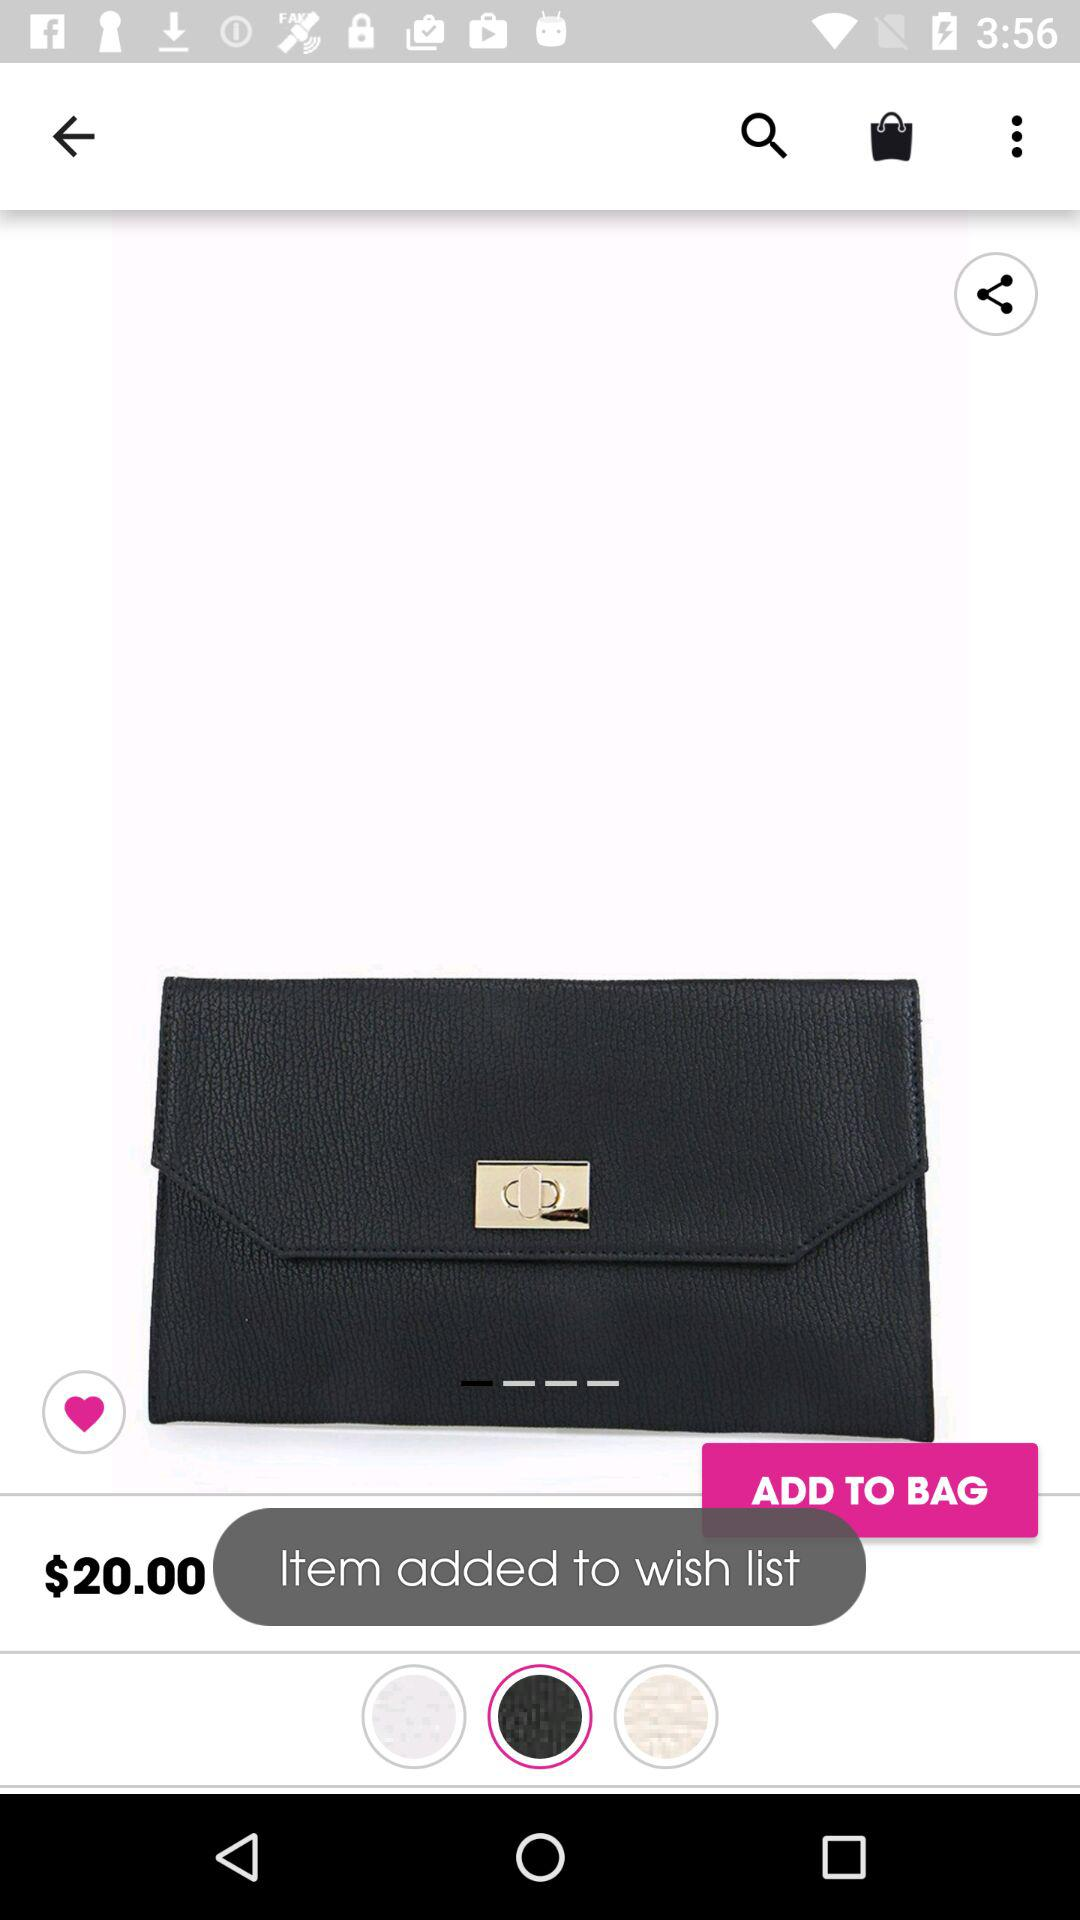What is the price of the item? The price of the item is $20. 